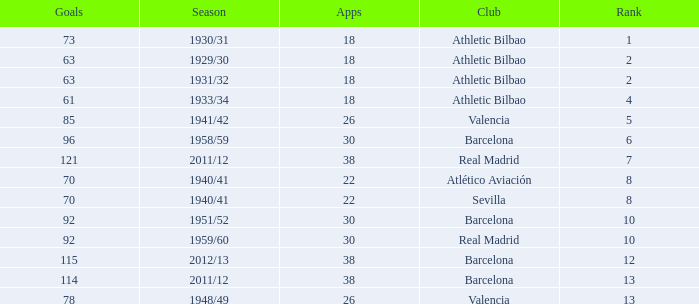How many apps when the rank was after 13 and having more than 73 goals? None. 